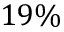Convert formula to latex. <formula><loc_0><loc_0><loc_500><loc_500>1 9 \%</formula> 